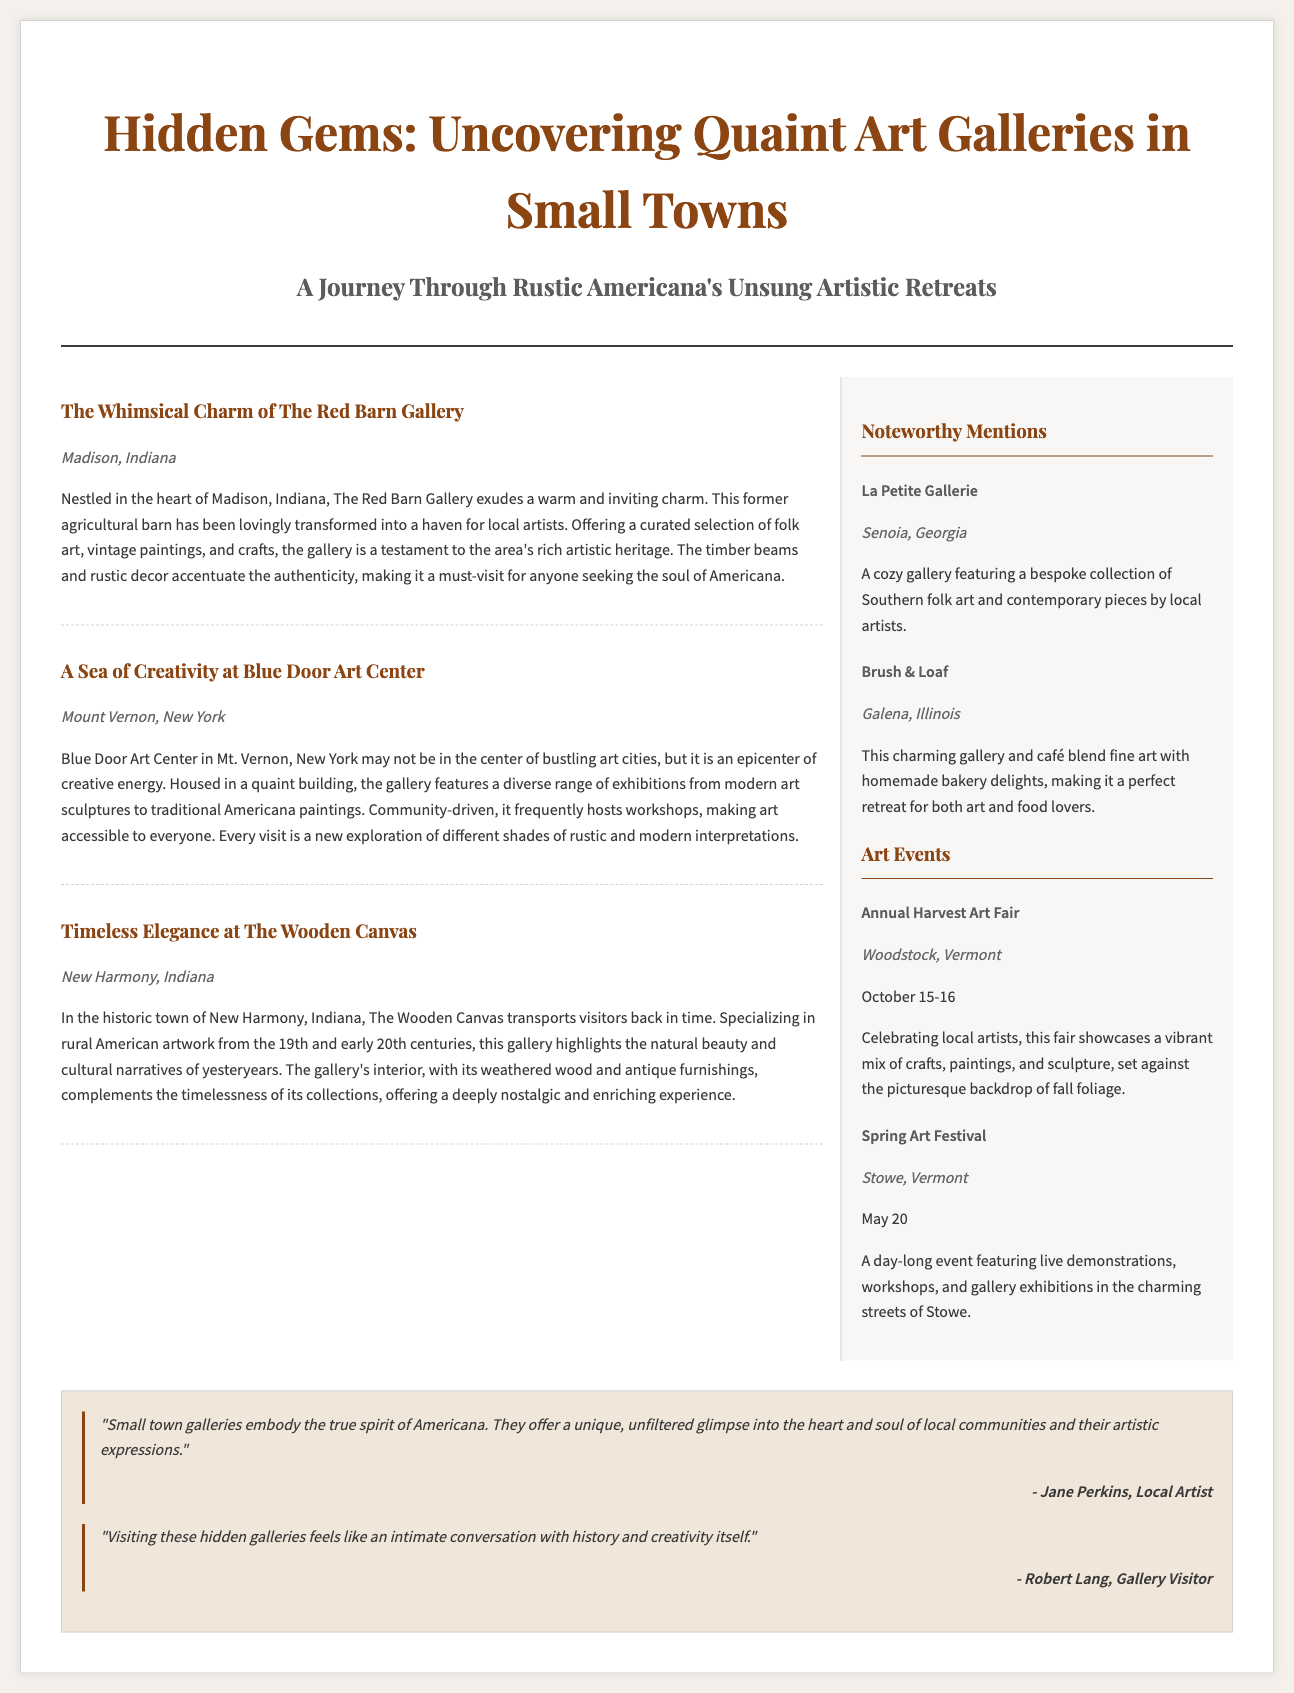What is the title of the article? The title of the article is provided in the header section of the document, which is "Hidden Gems: Uncovering Quaint Art Galleries in Small Towns."
Answer: Hidden Gems: Uncovering Quaint Art Galleries in Small Towns What town is The Red Barn Gallery located in? The location of The Red Barn Gallery is specified under the article title, which is Madison, Indiana.
Answer: Madison, Indiana What type of art does The Wooden Canvas specialize in? The Wooden Canvas specializes in rural American artwork from the 19th and early 20th centuries, as mentioned in its description.
Answer: Rural American artwork When does the Annual Harvest Art Fair take place? The document states that the Annual Harvest Art Fair occurs on October 15-16.
Answer: October 15-16 What unique feature does Brush & Loaf offer? Brush & Loaf combines fine art with homemade bakery delights, making it a unique café and gallery.
Answer: Homemade bakery delights Which artist quoted in the document describes small town galleries? Jane Perkins is quoted in the document about small town galleries embodying the true spirit of Americana.
Answer: Jane Perkins How many galleries are listed in the Noteworthy Mentions section? The Noteworthy Mentions section lists two galleries: La Petite Gallerie and Brush & Loaf.
Answer: Two Which event features live demonstrations and workshops? The Spring Art Festival is the event mentioned that features live demonstrations and workshops.
Answer: Spring Art Festival 